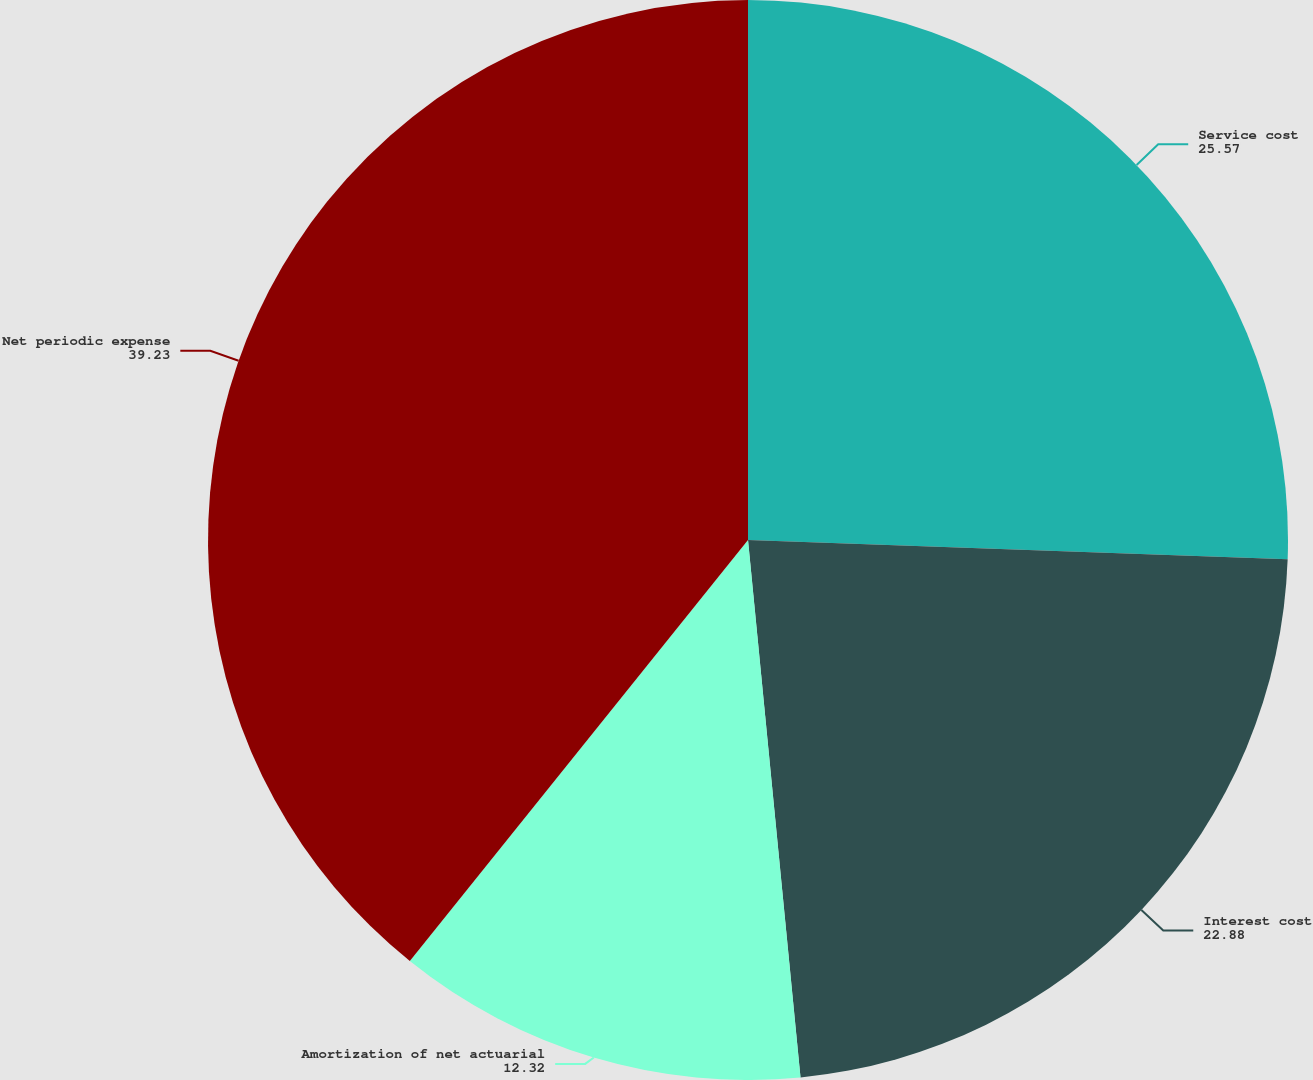Convert chart. <chart><loc_0><loc_0><loc_500><loc_500><pie_chart><fcel>Service cost<fcel>Interest cost<fcel>Amortization of net actuarial<fcel>Net periodic expense<nl><fcel>25.57%<fcel>22.88%<fcel>12.32%<fcel>39.23%<nl></chart> 